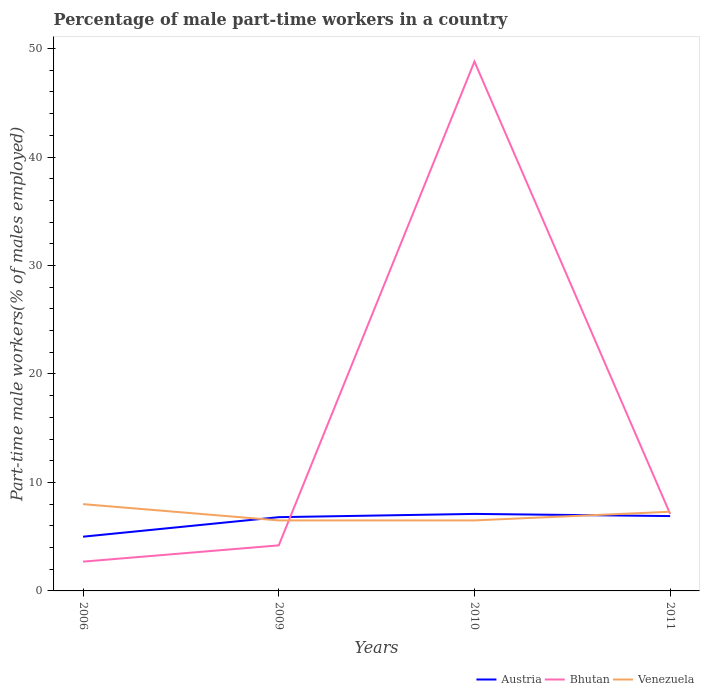How many different coloured lines are there?
Make the answer very short. 3. Does the line corresponding to Venezuela intersect with the line corresponding to Bhutan?
Provide a succinct answer. Yes. Is the number of lines equal to the number of legend labels?
Ensure brevity in your answer.  Yes. Across all years, what is the maximum percentage of male part-time workers in Bhutan?
Keep it short and to the point. 2.7. What is the total percentage of male part-time workers in Bhutan in the graph?
Offer a terse response. -2.9. What is the difference between the highest and the second highest percentage of male part-time workers in Bhutan?
Your answer should be very brief. 46.1. How many years are there in the graph?
Offer a very short reply. 4. What is the difference between two consecutive major ticks on the Y-axis?
Keep it short and to the point. 10. Does the graph contain any zero values?
Offer a terse response. No. What is the title of the graph?
Keep it short and to the point. Percentage of male part-time workers in a country. Does "Caribbean small states" appear as one of the legend labels in the graph?
Give a very brief answer. No. What is the label or title of the X-axis?
Your answer should be very brief. Years. What is the label or title of the Y-axis?
Make the answer very short. Part-time male workers(% of males employed). What is the Part-time male workers(% of males employed) of Austria in 2006?
Your answer should be very brief. 5. What is the Part-time male workers(% of males employed) of Bhutan in 2006?
Make the answer very short. 2.7. What is the Part-time male workers(% of males employed) of Austria in 2009?
Your answer should be very brief. 6.8. What is the Part-time male workers(% of males employed) in Bhutan in 2009?
Your answer should be very brief. 4.2. What is the Part-time male workers(% of males employed) in Venezuela in 2009?
Make the answer very short. 6.5. What is the Part-time male workers(% of males employed) in Austria in 2010?
Your answer should be compact. 7.1. What is the Part-time male workers(% of males employed) of Bhutan in 2010?
Provide a short and direct response. 48.8. What is the Part-time male workers(% of males employed) in Austria in 2011?
Ensure brevity in your answer.  6.9. What is the Part-time male workers(% of males employed) of Bhutan in 2011?
Give a very brief answer. 7.1. What is the Part-time male workers(% of males employed) in Venezuela in 2011?
Your response must be concise. 7.3. Across all years, what is the maximum Part-time male workers(% of males employed) of Austria?
Provide a short and direct response. 7.1. Across all years, what is the maximum Part-time male workers(% of males employed) of Bhutan?
Your answer should be compact. 48.8. Across all years, what is the minimum Part-time male workers(% of males employed) in Austria?
Your answer should be compact. 5. Across all years, what is the minimum Part-time male workers(% of males employed) in Bhutan?
Your response must be concise. 2.7. Across all years, what is the minimum Part-time male workers(% of males employed) of Venezuela?
Make the answer very short. 6.5. What is the total Part-time male workers(% of males employed) of Austria in the graph?
Give a very brief answer. 25.8. What is the total Part-time male workers(% of males employed) of Bhutan in the graph?
Give a very brief answer. 62.8. What is the total Part-time male workers(% of males employed) of Venezuela in the graph?
Ensure brevity in your answer.  28.3. What is the difference between the Part-time male workers(% of males employed) in Venezuela in 2006 and that in 2009?
Make the answer very short. 1.5. What is the difference between the Part-time male workers(% of males employed) of Austria in 2006 and that in 2010?
Provide a short and direct response. -2.1. What is the difference between the Part-time male workers(% of males employed) in Bhutan in 2006 and that in 2010?
Your answer should be compact. -46.1. What is the difference between the Part-time male workers(% of males employed) of Venezuela in 2006 and that in 2010?
Ensure brevity in your answer.  1.5. What is the difference between the Part-time male workers(% of males employed) of Austria in 2009 and that in 2010?
Your response must be concise. -0.3. What is the difference between the Part-time male workers(% of males employed) in Bhutan in 2009 and that in 2010?
Offer a terse response. -44.6. What is the difference between the Part-time male workers(% of males employed) in Austria in 2010 and that in 2011?
Keep it short and to the point. 0.2. What is the difference between the Part-time male workers(% of males employed) in Bhutan in 2010 and that in 2011?
Your response must be concise. 41.7. What is the difference between the Part-time male workers(% of males employed) in Venezuela in 2010 and that in 2011?
Offer a terse response. -0.8. What is the difference between the Part-time male workers(% of males employed) in Austria in 2006 and the Part-time male workers(% of males employed) in Bhutan in 2009?
Offer a very short reply. 0.8. What is the difference between the Part-time male workers(% of males employed) of Austria in 2006 and the Part-time male workers(% of males employed) of Venezuela in 2009?
Provide a succinct answer. -1.5. What is the difference between the Part-time male workers(% of males employed) in Bhutan in 2006 and the Part-time male workers(% of males employed) in Venezuela in 2009?
Your answer should be compact. -3.8. What is the difference between the Part-time male workers(% of males employed) in Austria in 2006 and the Part-time male workers(% of males employed) in Bhutan in 2010?
Provide a succinct answer. -43.8. What is the difference between the Part-time male workers(% of males employed) of Bhutan in 2006 and the Part-time male workers(% of males employed) of Venezuela in 2010?
Offer a terse response. -3.8. What is the difference between the Part-time male workers(% of males employed) in Austria in 2009 and the Part-time male workers(% of males employed) in Bhutan in 2010?
Make the answer very short. -42. What is the difference between the Part-time male workers(% of males employed) of Austria in 2010 and the Part-time male workers(% of males employed) of Bhutan in 2011?
Your response must be concise. 0. What is the difference between the Part-time male workers(% of males employed) of Bhutan in 2010 and the Part-time male workers(% of males employed) of Venezuela in 2011?
Keep it short and to the point. 41.5. What is the average Part-time male workers(% of males employed) in Austria per year?
Keep it short and to the point. 6.45. What is the average Part-time male workers(% of males employed) in Bhutan per year?
Provide a succinct answer. 15.7. What is the average Part-time male workers(% of males employed) of Venezuela per year?
Provide a succinct answer. 7.08. In the year 2006, what is the difference between the Part-time male workers(% of males employed) of Austria and Part-time male workers(% of males employed) of Bhutan?
Ensure brevity in your answer.  2.3. In the year 2006, what is the difference between the Part-time male workers(% of males employed) of Bhutan and Part-time male workers(% of males employed) of Venezuela?
Make the answer very short. -5.3. In the year 2009, what is the difference between the Part-time male workers(% of males employed) of Austria and Part-time male workers(% of males employed) of Bhutan?
Ensure brevity in your answer.  2.6. In the year 2009, what is the difference between the Part-time male workers(% of males employed) of Bhutan and Part-time male workers(% of males employed) of Venezuela?
Provide a succinct answer. -2.3. In the year 2010, what is the difference between the Part-time male workers(% of males employed) of Austria and Part-time male workers(% of males employed) of Bhutan?
Make the answer very short. -41.7. In the year 2010, what is the difference between the Part-time male workers(% of males employed) of Bhutan and Part-time male workers(% of males employed) of Venezuela?
Make the answer very short. 42.3. In the year 2011, what is the difference between the Part-time male workers(% of males employed) in Bhutan and Part-time male workers(% of males employed) in Venezuela?
Make the answer very short. -0.2. What is the ratio of the Part-time male workers(% of males employed) of Austria in 2006 to that in 2009?
Make the answer very short. 0.74. What is the ratio of the Part-time male workers(% of males employed) in Bhutan in 2006 to that in 2009?
Provide a short and direct response. 0.64. What is the ratio of the Part-time male workers(% of males employed) of Venezuela in 2006 to that in 2009?
Your response must be concise. 1.23. What is the ratio of the Part-time male workers(% of males employed) of Austria in 2006 to that in 2010?
Offer a terse response. 0.7. What is the ratio of the Part-time male workers(% of males employed) of Bhutan in 2006 to that in 2010?
Your response must be concise. 0.06. What is the ratio of the Part-time male workers(% of males employed) of Venezuela in 2006 to that in 2010?
Keep it short and to the point. 1.23. What is the ratio of the Part-time male workers(% of males employed) of Austria in 2006 to that in 2011?
Provide a short and direct response. 0.72. What is the ratio of the Part-time male workers(% of males employed) of Bhutan in 2006 to that in 2011?
Give a very brief answer. 0.38. What is the ratio of the Part-time male workers(% of males employed) in Venezuela in 2006 to that in 2011?
Ensure brevity in your answer.  1.1. What is the ratio of the Part-time male workers(% of males employed) of Austria in 2009 to that in 2010?
Your response must be concise. 0.96. What is the ratio of the Part-time male workers(% of males employed) in Bhutan in 2009 to that in 2010?
Make the answer very short. 0.09. What is the ratio of the Part-time male workers(% of males employed) in Austria in 2009 to that in 2011?
Keep it short and to the point. 0.99. What is the ratio of the Part-time male workers(% of males employed) in Bhutan in 2009 to that in 2011?
Ensure brevity in your answer.  0.59. What is the ratio of the Part-time male workers(% of males employed) of Venezuela in 2009 to that in 2011?
Offer a very short reply. 0.89. What is the ratio of the Part-time male workers(% of males employed) in Bhutan in 2010 to that in 2011?
Offer a terse response. 6.87. What is the ratio of the Part-time male workers(% of males employed) in Venezuela in 2010 to that in 2011?
Your answer should be very brief. 0.89. What is the difference between the highest and the second highest Part-time male workers(% of males employed) of Austria?
Offer a very short reply. 0.2. What is the difference between the highest and the second highest Part-time male workers(% of males employed) of Bhutan?
Provide a short and direct response. 41.7. What is the difference between the highest and the second highest Part-time male workers(% of males employed) of Venezuela?
Provide a short and direct response. 0.7. What is the difference between the highest and the lowest Part-time male workers(% of males employed) of Austria?
Offer a terse response. 2.1. What is the difference between the highest and the lowest Part-time male workers(% of males employed) in Bhutan?
Provide a short and direct response. 46.1. What is the difference between the highest and the lowest Part-time male workers(% of males employed) of Venezuela?
Provide a short and direct response. 1.5. 